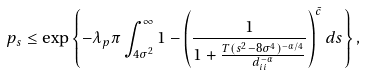Convert formula to latex. <formula><loc_0><loc_0><loc_500><loc_500>p _ { s } \leq \exp \left \{ - \lambda _ { p } \pi \int _ { 4 \sigma ^ { 2 } } ^ { \infty } 1 - \left ( \frac { 1 } { 1 + \frac { T ( s ^ { 2 } - 8 \sigma ^ { 4 } ) ^ { - \alpha / 4 } } { d _ { i i } ^ { - \alpha } } } \right ) ^ { \bar { c } } d s \right \} ,</formula> 